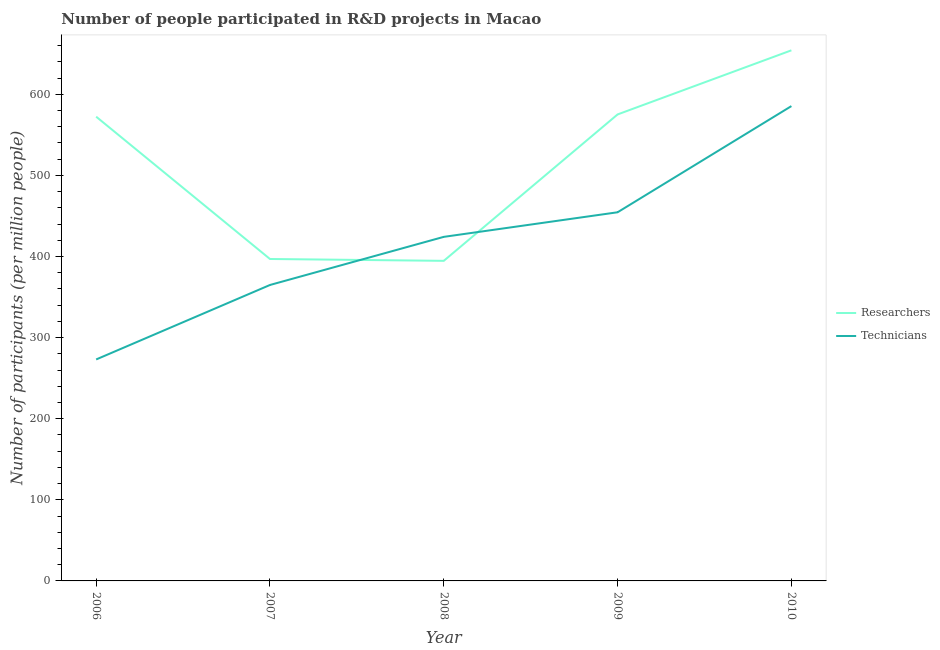Does the line corresponding to number of researchers intersect with the line corresponding to number of technicians?
Provide a short and direct response. Yes. Is the number of lines equal to the number of legend labels?
Your response must be concise. Yes. What is the number of researchers in 2009?
Provide a succinct answer. 575.18. Across all years, what is the maximum number of researchers?
Offer a terse response. 654.21. Across all years, what is the minimum number of researchers?
Provide a short and direct response. 394.66. What is the total number of technicians in the graph?
Ensure brevity in your answer.  2102.19. What is the difference between the number of technicians in 2007 and that in 2010?
Make the answer very short. -220.56. What is the difference between the number of researchers in 2010 and the number of technicians in 2006?
Give a very brief answer. 381.14. What is the average number of technicians per year?
Provide a short and direct response. 420.44. In the year 2010, what is the difference between the number of researchers and number of technicians?
Your answer should be very brief. 68.76. In how many years, is the number of technicians greater than 460?
Your answer should be very brief. 1. What is the ratio of the number of technicians in 2006 to that in 2009?
Provide a succinct answer. 0.6. What is the difference between the highest and the second highest number of researchers?
Offer a terse response. 79.04. What is the difference between the highest and the lowest number of technicians?
Offer a terse response. 312.38. Does the number of researchers monotonically increase over the years?
Make the answer very short. No. Is the number of technicians strictly greater than the number of researchers over the years?
Offer a very short reply. No. How many lines are there?
Your answer should be compact. 2. Does the graph contain grids?
Provide a short and direct response. No. How many legend labels are there?
Your answer should be very brief. 2. How are the legend labels stacked?
Ensure brevity in your answer.  Vertical. What is the title of the graph?
Offer a very short reply. Number of people participated in R&D projects in Macao. Does "Time to import" appear as one of the legend labels in the graph?
Make the answer very short. No. What is the label or title of the X-axis?
Your response must be concise. Year. What is the label or title of the Y-axis?
Make the answer very short. Number of participants (per million people). What is the Number of participants (per million people) of Researchers in 2006?
Make the answer very short. 572.41. What is the Number of participants (per million people) of Technicians in 2006?
Give a very brief answer. 273.07. What is the Number of participants (per million people) in Researchers in 2007?
Offer a terse response. 396.94. What is the Number of participants (per million people) in Technicians in 2007?
Your response must be concise. 364.89. What is the Number of participants (per million people) in Researchers in 2008?
Make the answer very short. 394.66. What is the Number of participants (per million people) of Technicians in 2008?
Give a very brief answer. 424.23. What is the Number of participants (per million people) in Researchers in 2009?
Make the answer very short. 575.18. What is the Number of participants (per million people) of Technicians in 2009?
Your answer should be compact. 454.54. What is the Number of participants (per million people) of Researchers in 2010?
Your response must be concise. 654.21. What is the Number of participants (per million people) of Technicians in 2010?
Make the answer very short. 585.46. Across all years, what is the maximum Number of participants (per million people) in Researchers?
Your response must be concise. 654.21. Across all years, what is the maximum Number of participants (per million people) of Technicians?
Keep it short and to the point. 585.46. Across all years, what is the minimum Number of participants (per million people) in Researchers?
Offer a very short reply. 394.66. Across all years, what is the minimum Number of participants (per million people) of Technicians?
Give a very brief answer. 273.07. What is the total Number of participants (per million people) of Researchers in the graph?
Offer a very short reply. 2593.4. What is the total Number of participants (per million people) of Technicians in the graph?
Offer a very short reply. 2102.19. What is the difference between the Number of participants (per million people) in Researchers in 2006 and that in 2007?
Offer a very short reply. 175.47. What is the difference between the Number of participants (per million people) of Technicians in 2006 and that in 2007?
Make the answer very short. -91.82. What is the difference between the Number of participants (per million people) in Researchers in 2006 and that in 2008?
Provide a short and direct response. 177.75. What is the difference between the Number of participants (per million people) of Technicians in 2006 and that in 2008?
Provide a short and direct response. -151.16. What is the difference between the Number of participants (per million people) of Researchers in 2006 and that in 2009?
Give a very brief answer. -2.77. What is the difference between the Number of participants (per million people) of Technicians in 2006 and that in 2009?
Give a very brief answer. -181.47. What is the difference between the Number of participants (per million people) in Researchers in 2006 and that in 2010?
Your answer should be very brief. -81.81. What is the difference between the Number of participants (per million people) in Technicians in 2006 and that in 2010?
Your answer should be very brief. -312.38. What is the difference between the Number of participants (per million people) of Researchers in 2007 and that in 2008?
Keep it short and to the point. 2.28. What is the difference between the Number of participants (per million people) of Technicians in 2007 and that in 2008?
Keep it short and to the point. -59.34. What is the difference between the Number of participants (per million people) of Researchers in 2007 and that in 2009?
Provide a succinct answer. -178.24. What is the difference between the Number of participants (per million people) of Technicians in 2007 and that in 2009?
Keep it short and to the point. -89.65. What is the difference between the Number of participants (per million people) of Researchers in 2007 and that in 2010?
Your answer should be very brief. -257.27. What is the difference between the Number of participants (per million people) in Technicians in 2007 and that in 2010?
Your answer should be compact. -220.56. What is the difference between the Number of participants (per million people) in Researchers in 2008 and that in 2009?
Offer a terse response. -180.52. What is the difference between the Number of participants (per million people) in Technicians in 2008 and that in 2009?
Your answer should be compact. -30.31. What is the difference between the Number of participants (per million people) in Researchers in 2008 and that in 2010?
Your answer should be compact. -259.56. What is the difference between the Number of participants (per million people) of Technicians in 2008 and that in 2010?
Give a very brief answer. -161.23. What is the difference between the Number of participants (per million people) of Researchers in 2009 and that in 2010?
Provide a short and direct response. -79.04. What is the difference between the Number of participants (per million people) of Technicians in 2009 and that in 2010?
Keep it short and to the point. -130.91. What is the difference between the Number of participants (per million people) of Researchers in 2006 and the Number of participants (per million people) of Technicians in 2007?
Offer a very short reply. 207.52. What is the difference between the Number of participants (per million people) of Researchers in 2006 and the Number of participants (per million people) of Technicians in 2008?
Your answer should be compact. 148.18. What is the difference between the Number of participants (per million people) in Researchers in 2006 and the Number of participants (per million people) in Technicians in 2009?
Offer a very short reply. 117.87. What is the difference between the Number of participants (per million people) in Researchers in 2006 and the Number of participants (per million people) in Technicians in 2010?
Offer a terse response. -13.05. What is the difference between the Number of participants (per million people) in Researchers in 2007 and the Number of participants (per million people) in Technicians in 2008?
Give a very brief answer. -27.29. What is the difference between the Number of participants (per million people) in Researchers in 2007 and the Number of participants (per million people) in Technicians in 2009?
Your answer should be very brief. -57.6. What is the difference between the Number of participants (per million people) in Researchers in 2007 and the Number of participants (per million people) in Technicians in 2010?
Your answer should be very brief. -188.52. What is the difference between the Number of participants (per million people) of Researchers in 2008 and the Number of participants (per million people) of Technicians in 2009?
Provide a short and direct response. -59.88. What is the difference between the Number of participants (per million people) in Researchers in 2008 and the Number of participants (per million people) in Technicians in 2010?
Your answer should be compact. -190.8. What is the difference between the Number of participants (per million people) in Researchers in 2009 and the Number of participants (per million people) in Technicians in 2010?
Ensure brevity in your answer.  -10.28. What is the average Number of participants (per million people) in Researchers per year?
Offer a terse response. 518.68. What is the average Number of participants (per million people) in Technicians per year?
Ensure brevity in your answer.  420.44. In the year 2006, what is the difference between the Number of participants (per million people) of Researchers and Number of participants (per million people) of Technicians?
Provide a succinct answer. 299.34. In the year 2007, what is the difference between the Number of participants (per million people) in Researchers and Number of participants (per million people) in Technicians?
Ensure brevity in your answer.  32.05. In the year 2008, what is the difference between the Number of participants (per million people) in Researchers and Number of participants (per million people) in Technicians?
Ensure brevity in your answer.  -29.57. In the year 2009, what is the difference between the Number of participants (per million people) in Researchers and Number of participants (per million people) in Technicians?
Make the answer very short. 120.64. In the year 2010, what is the difference between the Number of participants (per million people) of Researchers and Number of participants (per million people) of Technicians?
Keep it short and to the point. 68.76. What is the ratio of the Number of participants (per million people) in Researchers in 2006 to that in 2007?
Offer a very short reply. 1.44. What is the ratio of the Number of participants (per million people) of Technicians in 2006 to that in 2007?
Offer a terse response. 0.75. What is the ratio of the Number of participants (per million people) of Researchers in 2006 to that in 2008?
Your response must be concise. 1.45. What is the ratio of the Number of participants (per million people) of Technicians in 2006 to that in 2008?
Your response must be concise. 0.64. What is the ratio of the Number of participants (per million people) of Technicians in 2006 to that in 2009?
Offer a terse response. 0.6. What is the ratio of the Number of participants (per million people) in Technicians in 2006 to that in 2010?
Ensure brevity in your answer.  0.47. What is the ratio of the Number of participants (per million people) in Technicians in 2007 to that in 2008?
Your response must be concise. 0.86. What is the ratio of the Number of participants (per million people) in Researchers in 2007 to that in 2009?
Provide a succinct answer. 0.69. What is the ratio of the Number of participants (per million people) of Technicians in 2007 to that in 2009?
Ensure brevity in your answer.  0.8. What is the ratio of the Number of participants (per million people) in Researchers in 2007 to that in 2010?
Your answer should be very brief. 0.61. What is the ratio of the Number of participants (per million people) in Technicians in 2007 to that in 2010?
Ensure brevity in your answer.  0.62. What is the ratio of the Number of participants (per million people) in Researchers in 2008 to that in 2009?
Give a very brief answer. 0.69. What is the ratio of the Number of participants (per million people) of Researchers in 2008 to that in 2010?
Your answer should be very brief. 0.6. What is the ratio of the Number of participants (per million people) in Technicians in 2008 to that in 2010?
Give a very brief answer. 0.72. What is the ratio of the Number of participants (per million people) in Researchers in 2009 to that in 2010?
Your answer should be compact. 0.88. What is the ratio of the Number of participants (per million people) in Technicians in 2009 to that in 2010?
Your answer should be compact. 0.78. What is the difference between the highest and the second highest Number of participants (per million people) in Researchers?
Keep it short and to the point. 79.04. What is the difference between the highest and the second highest Number of participants (per million people) of Technicians?
Provide a short and direct response. 130.91. What is the difference between the highest and the lowest Number of participants (per million people) of Researchers?
Offer a very short reply. 259.56. What is the difference between the highest and the lowest Number of participants (per million people) in Technicians?
Ensure brevity in your answer.  312.38. 